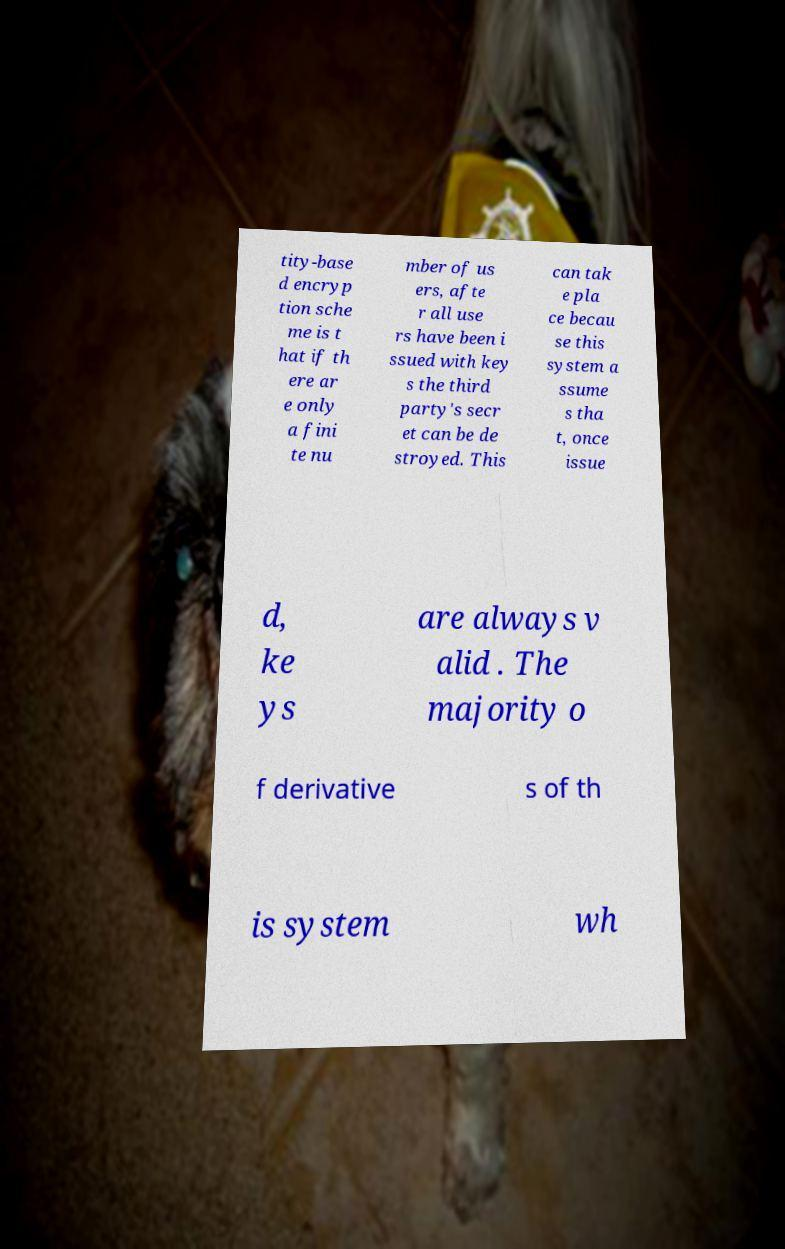Could you assist in decoding the text presented in this image and type it out clearly? tity-base d encryp tion sche me is t hat if th ere ar e only a fini te nu mber of us ers, afte r all use rs have been i ssued with key s the third party's secr et can be de stroyed. This can tak e pla ce becau se this system a ssume s tha t, once issue d, ke ys are always v alid . The majority o f derivative s of th is system wh 